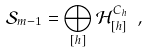<formula> <loc_0><loc_0><loc_500><loc_500>\mathcal { S } _ { m - 1 } = \bigoplus _ { [ h ] } \mathcal { H } ^ { C _ { h } } _ { [ h ] } \ ,</formula> 